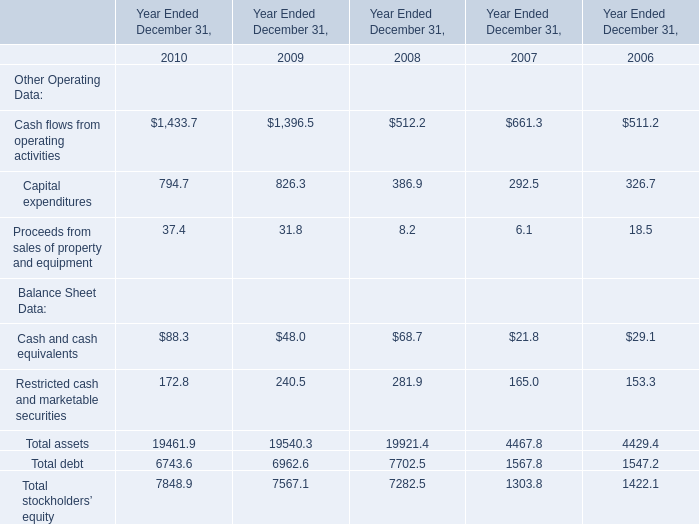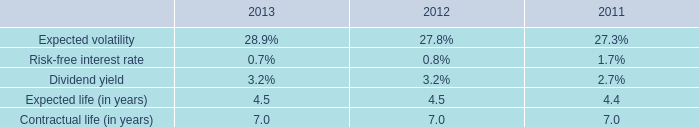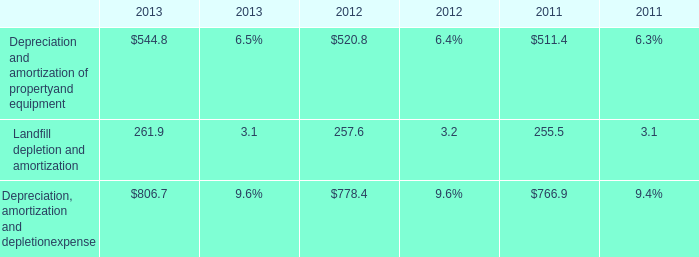What's the average of Proceeds from sales of property and equipment and Capital expenditures in 2010? 
Computations: ((794.7 + 37.4) / 2)
Answer: 416.05. 